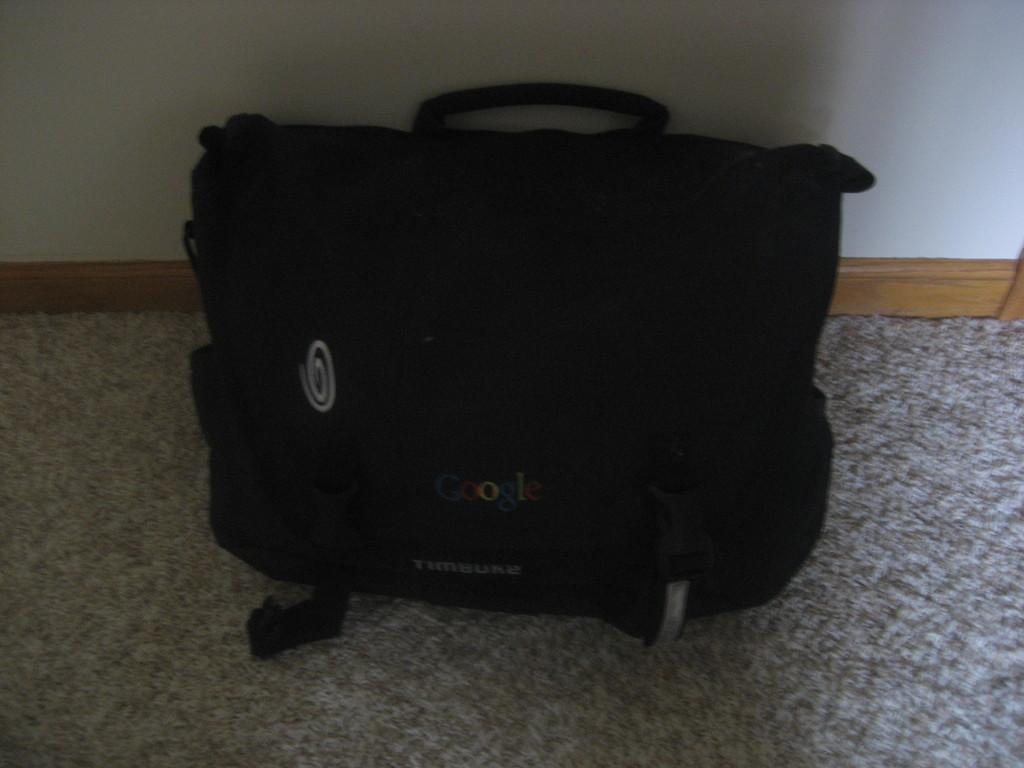What object is present in the image that can be used for carrying items? There is a bag in the image that can be used for carrying items. What is the color of the bag in the image? The bag is black in color. Is there any text on the bag? Yes, there is text written on the bag. On what surface is the bag placed? The bag is placed on a carpet. What can be seen behind the bag in the image? There is a wall behind the bag. What type of locket can be seen hanging from the bag in the image? There is no locket present on the bag in the image. Can you tell me how many crackers are visible on the carpet near the bag? There are no crackers visible on the carpet near the bag in the image. 